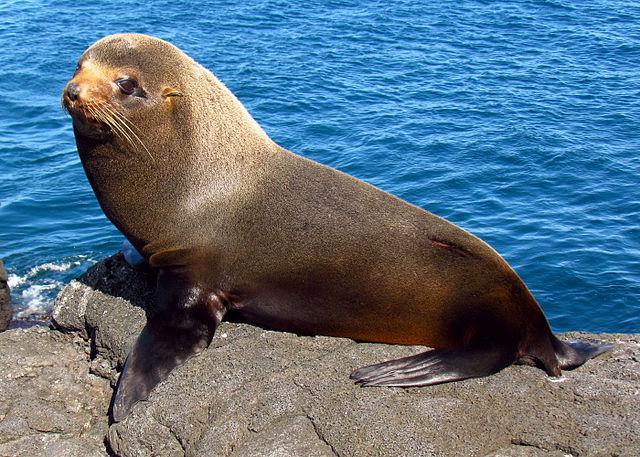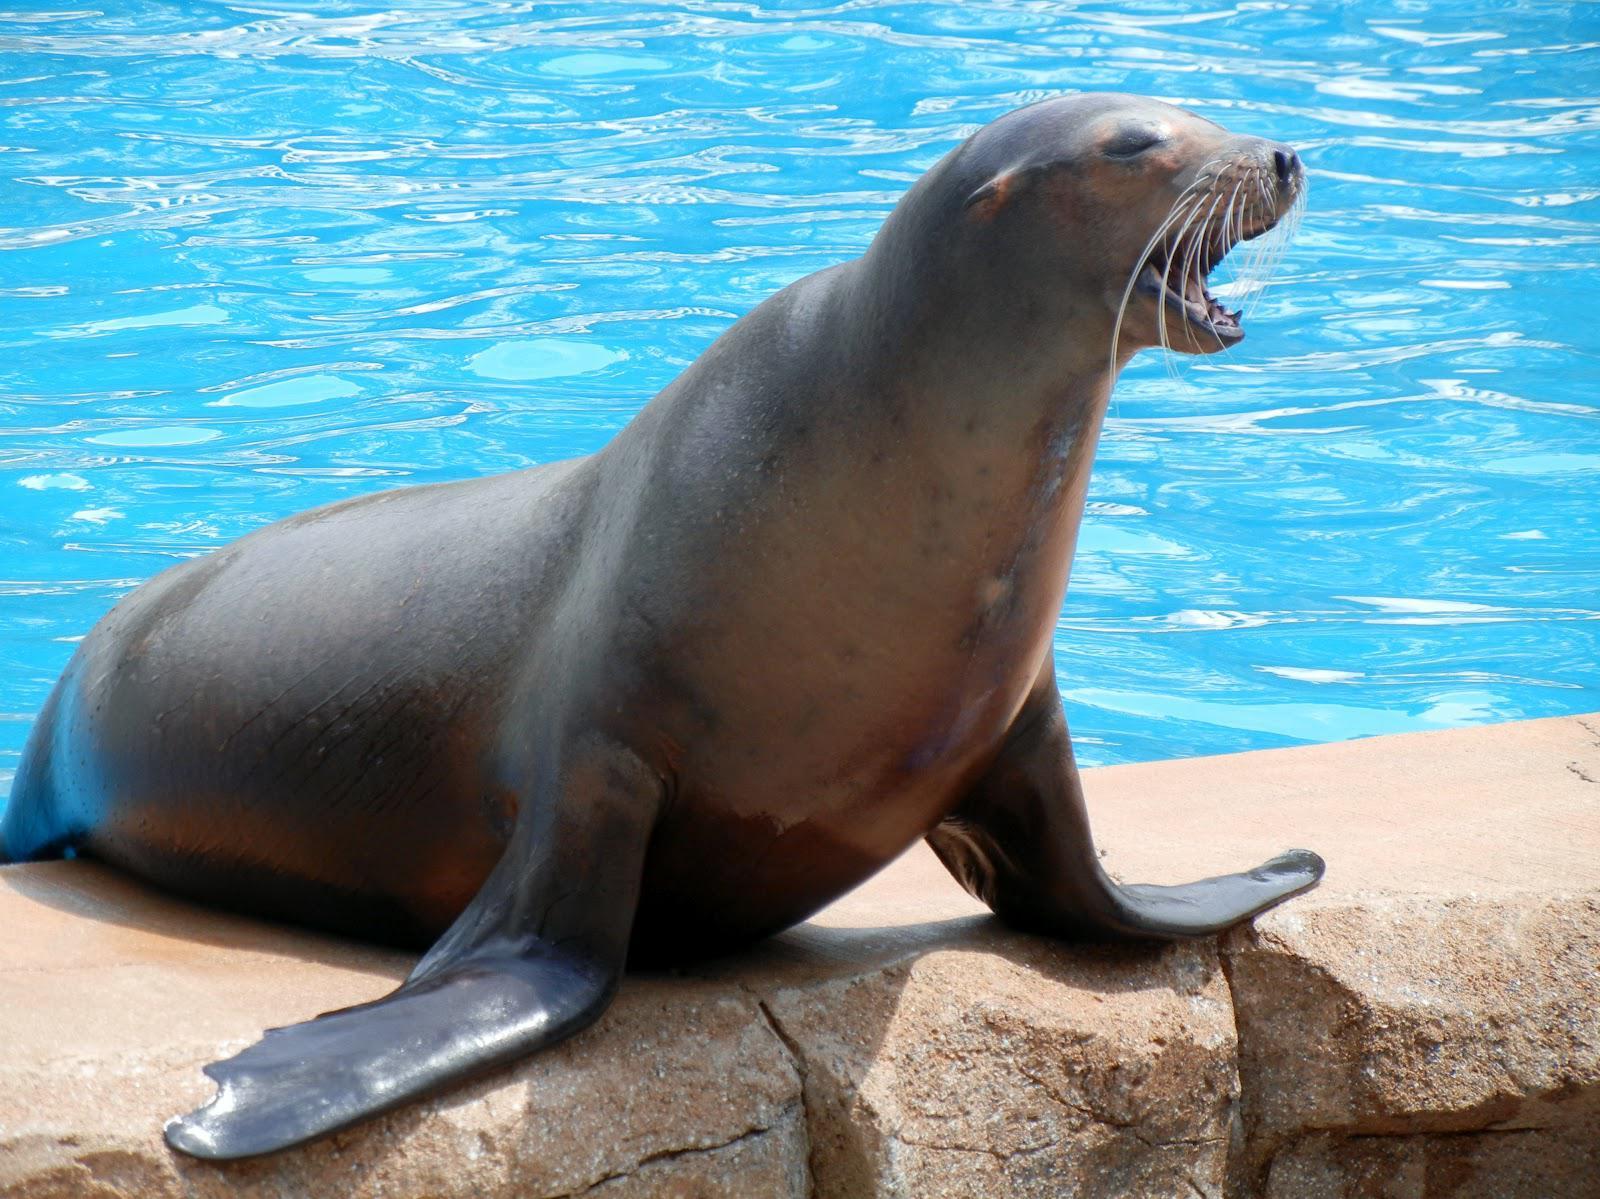The first image is the image on the left, the second image is the image on the right. Analyze the images presented: Is the assertion "In one of the images there is a single seal next to the edge of a swimming pool." valid? Answer yes or no. Yes. 